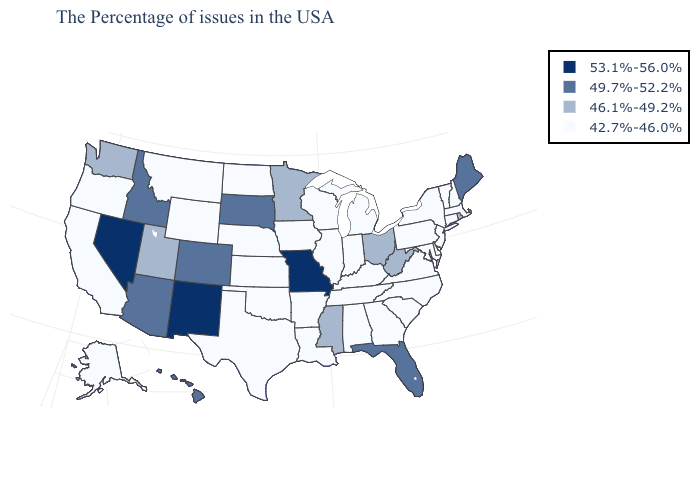What is the value of Indiana?
Keep it brief. 42.7%-46.0%. What is the value of Minnesota?
Write a very short answer. 46.1%-49.2%. Does Idaho have a higher value than Louisiana?
Be succinct. Yes. Among the states that border West Virginia , does Virginia have the highest value?
Answer briefly. No. What is the value of Idaho?
Write a very short answer. 49.7%-52.2%. Which states have the lowest value in the Northeast?
Quick response, please. Massachusetts, New Hampshire, Vermont, Connecticut, New York, New Jersey, Pennsylvania. Does Hawaii have a lower value than Kansas?
Keep it brief. No. What is the value of Delaware?
Keep it brief. 42.7%-46.0%. Which states hav the highest value in the South?
Keep it brief. Florida. What is the value of Illinois?
Concise answer only. 42.7%-46.0%. Among the states that border Nebraska , which have the lowest value?
Be succinct. Iowa, Kansas, Wyoming. What is the highest value in the USA?
Short answer required. 53.1%-56.0%. Does the map have missing data?
Give a very brief answer. No. Among the states that border New Hampshire , which have the highest value?
Short answer required. Maine. What is the value of Louisiana?
Keep it brief. 42.7%-46.0%. 